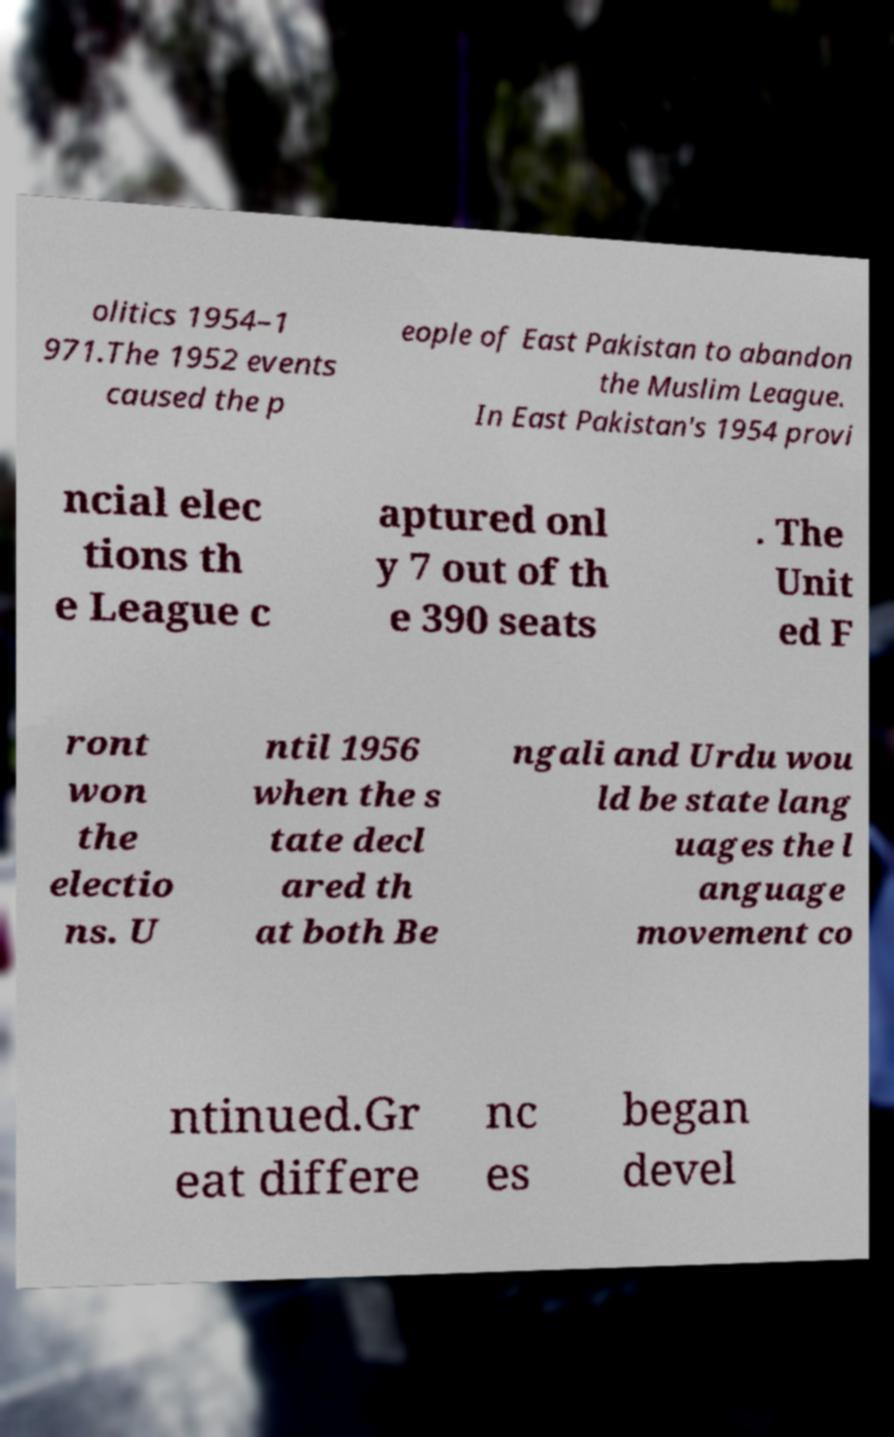Can you read and provide the text displayed in the image?This photo seems to have some interesting text. Can you extract and type it out for me? olitics 1954–1 971.The 1952 events caused the p eople of East Pakistan to abandon the Muslim League. In East Pakistan's 1954 provi ncial elec tions th e League c aptured onl y 7 out of th e 390 seats . The Unit ed F ront won the electio ns. U ntil 1956 when the s tate decl ared th at both Be ngali and Urdu wou ld be state lang uages the l anguage movement co ntinued.Gr eat differe nc es began devel 